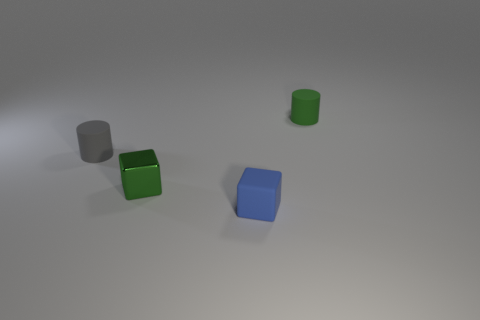The matte cylinder that is in front of the tiny rubber cylinder right of the rubber cylinder in front of the tiny green cylinder is what color?
Provide a succinct answer. Gray. Is the color of the tiny cylinder that is to the right of the small blue rubber thing the same as the small metal thing?
Provide a succinct answer. Yes. How many other things are there of the same color as the metallic block?
Your answer should be very brief. 1. What number of things are either small shiny blocks or small green rubber things?
Your response must be concise. 2. What number of things are either metal objects or small gray matte objects that are behind the green cube?
Ensure brevity in your answer.  2. Is the small green block made of the same material as the small gray thing?
Your answer should be compact. No. How many other objects are the same material as the small blue cube?
Provide a succinct answer. 2. Is the number of green metal things greater than the number of big blue balls?
Keep it short and to the point. Yes. There is a matte thing that is in front of the small metal block; is its shape the same as the tiny gray object?
Your response must be concise. No. Is the number of small rubber balls less than the number of rubber things?
Your answer should be compact. Yes. 